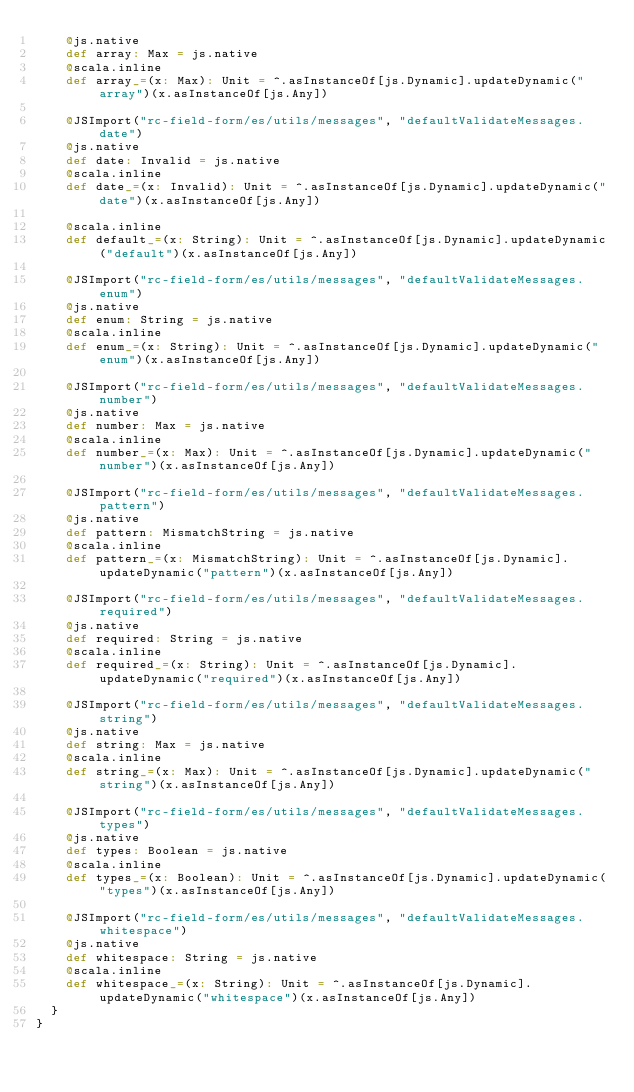<code> <loc_0><loc_0><loc_500><loc_500><_Scala_>    @js.native
    def array: Max = js.native
    @scala.inline
    def array_=(x: Max): Unit = ^.asInstanceOf[js.Dynamic].updateDynamic("array")(x.asInstanceOf[js.Any])
    
    @JSImport("rc-field-form/es/utils/messages", "defaultValidateMessages.date")
    @js.native
    def date: Invalid = js.native
    @scala.inline
    def date_=(x: Invalid): Unit = ^.asInstanceOf[js.Dynamic].updateDynamic("date")(x.asInstanceOf[js.Any])
    
    @scala.inline
    def default_=(x: String): Unit = ^.asInstanceOf[js.Dynamic].updateDynamic("default")(x.asInstanceOf[js.Any])
    
    @JSImport("rc-field-form/es/utils/messages", "defaultValidateMessages.enum")
    @js.native
    def enum: String = js.native
    @scala.inline
    def enum_=(x: String): Unit = ^.asInstanceOf[js.Dynamic].updateDynamic("enum")(x.asInstanceOf[js.Any])
    
    @JSImport("rc-field-form/es/utils/messages", "defaultValidateMessages.number")
    @js.native
    def number: Max = js.native
    @scala.inline
    def number_=(x: Max): Unit = ^.asInstanceOf[js.Dynamic].updateDynamic("number")(x.asInstanceOf[js.Any])
    
    @JSImport("rc-field-form/es/utils/messages", "defaultValidateMessages.pattern")
    @js.native
    def pattern: MismatchString = js.native
    @scala.inline
    def pattern_=(x: MismatchString): Unit = ^.asInstanceOf[js.Dynamic].updateDynamic("pattern")(x.asInstanceOf[js.Any])
    
    @JSImport("rc-field-form/es/utils/messages", "defaultValidateMessages.required")
    @js.native
    def required: String = js.native
    @scala.inline
    def required_=(x: String): Unit = ^.asInstanceOf[js.Dynamic].updateDynamic("required")(x.asInstanceOf[js.Any])
    
    @JSImport("rc-field-form/es/utils/messages", "defaultValidateMessages.string")
    @js.native
    def string: Max = js.native
    @scala.inline
    def string_=(x: Max): Unit = ^.asInstanceOf[js.Dynamic].updateDynamic("string")(x.asInstanceOf[js.Any])
    
    @JSImport("rc-field-form/es/utils/messages", "defaultValidateMessages.types")
    @js.native
    def types: Boolean = js.native
    @scala.inline
    def types_=(x: Boolean): Unit = ^.asInstanceOf[js.Dynamic].updateDynamic("types")(x.asInstanceOf[js.Any])
    
    @JSImport("rc-field-form/es/utils/messages", "defaultValidateMessages.whitespace")
    @js.native
    def whitespace: String = js.native
    @scala.inline
    def whitespace_=(x: String): Unit = ^.asInstanceOf[js.Dynamic].updateDynamic("whitespace")(x.asInstanceOf[js.Any])
  }
}
</code> 